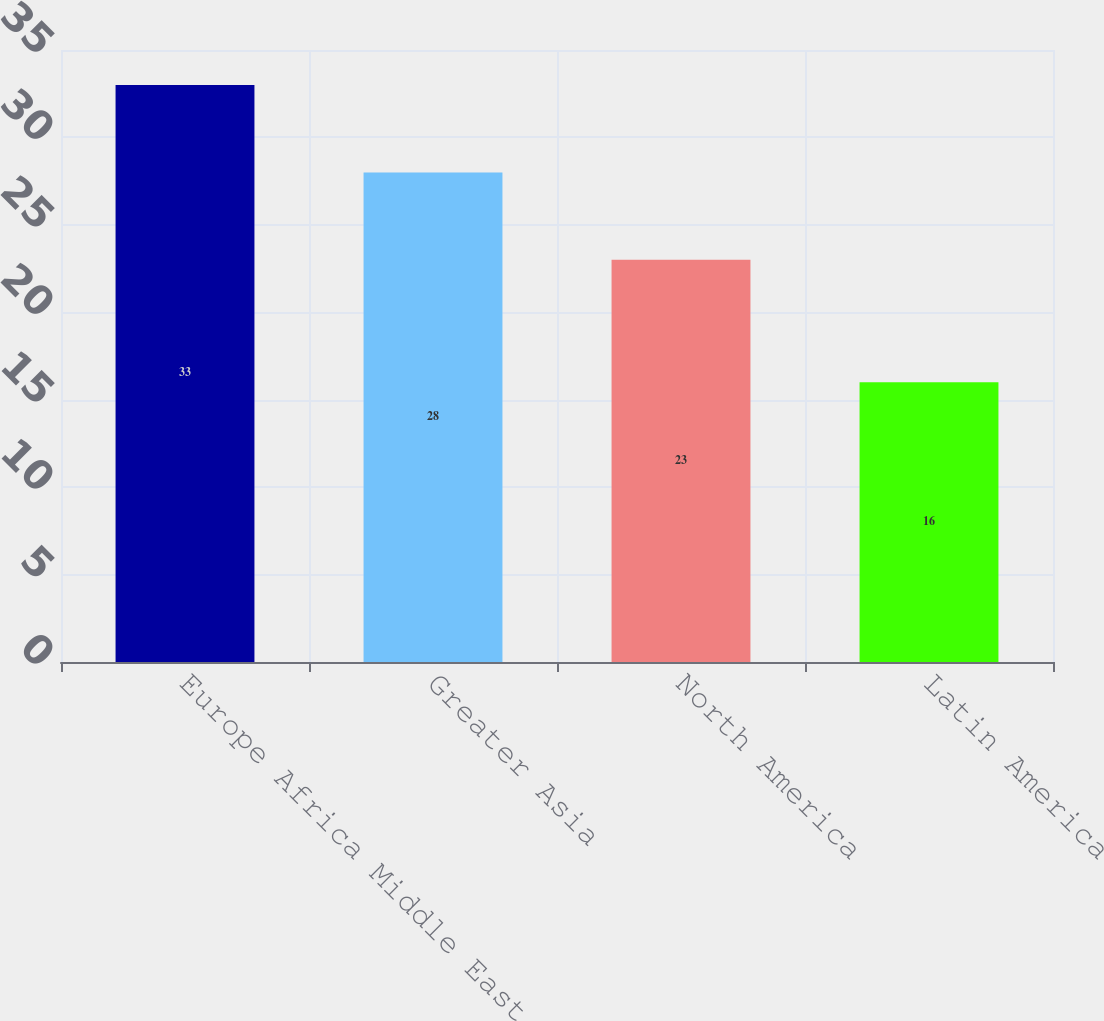<chart> <loc_0><loc_0><loc_500><loc_500><bar_chart><fcel>Europe Africa Middle East<fcel>Greater Asia<fcel>North America<fcel>Latin America<nl><fcel>33<fcel>28<fcel>23<fcel>16<nl></chart> 